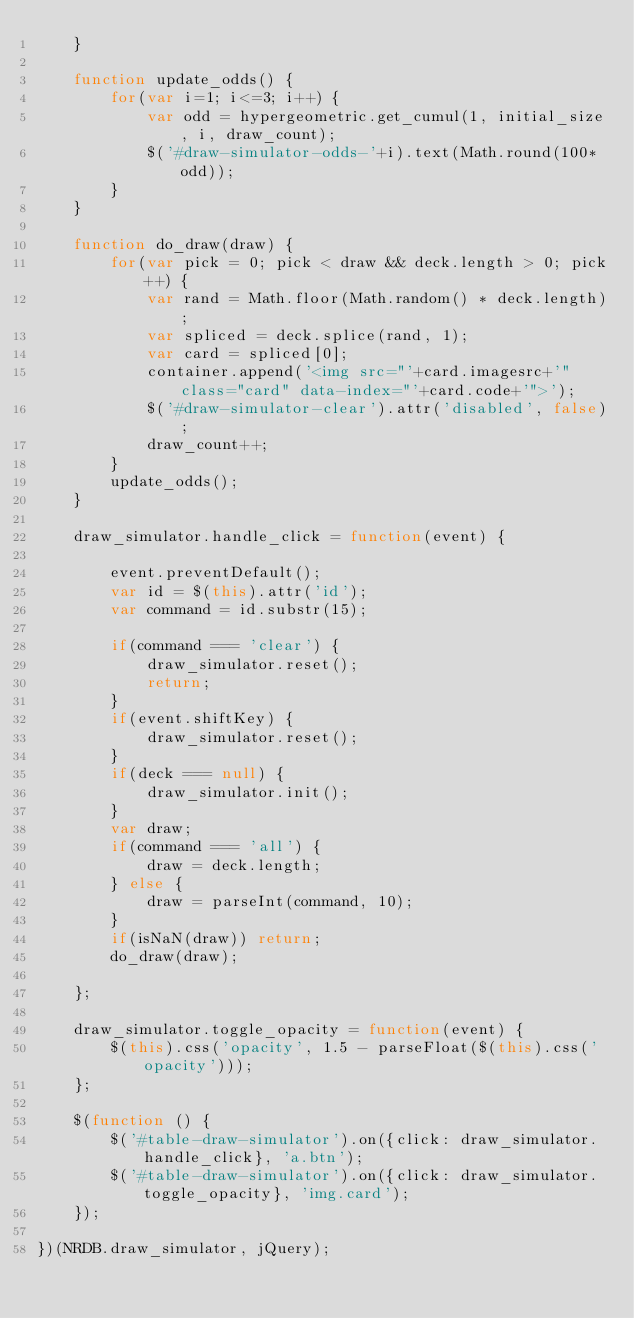Convert code to text. <code><loc_0><loc_0><loc_500><loc_500><_JavaScript_>	}

	function update_odds() {
		for(var i=1; i<=3; i++) {
			var odd = hypergeometric.get_cumul(1, initial_size, i, draw_count);
			$('#draw-simulator-odds-'+i).text(Math.round(100*odd));
		}
	}
	
	function do_draw(draw) {
		for(var pick = 0; pick < draw && deck.length > 0; pick++) {
			var rand = Math.floor(Math.random() * deck.length);
			var spliced = deck.splice(rand, 1);
			var card = spliced[0];
			container.append('<img src="'+card.imagesrc+'" class="card" data-index="'+card.code+'">');
			$('#draw-simulator-clear').attr('disabled', false);
			draw_count++;
		}
		update_odds();
	}
	
	draw_simulator.handle_click = function(event) {

		event.preventDefault();
		var id = $(this).attr('id');
		var command = id.substr(15);
		
		if(command === 'clear') {
			draw_simulator.reset();
			return;
		}
		if(event.shiftKey) {
			draw_simulator.reset();
		}
		if(deck === null) {
			draw_simulator.init();
		}
		var draw;
		if(command === 'all') {
			draw = deck.length;
		} else {
			draw = parseInt(command, 10);
		}
		if(isNaN(draw)) return;
		do_draw(draw);

	};
	
	draw_simulator.toggle_opacity = function(event) {
		$(this).css('opacity', 1.5 - parseFloat($(this).css('opacity')));
	};

	$(function () {
		$('#table-draw-simulator').on({click: draw_simulator.handle_click}, 'a.btn');
		$('#table-draw-simulator').on({click: draw_simulator.toggle_opacity}, 'img.card');
	});
	
})(NRDB.draw_simulator, jQuery);
</code> 